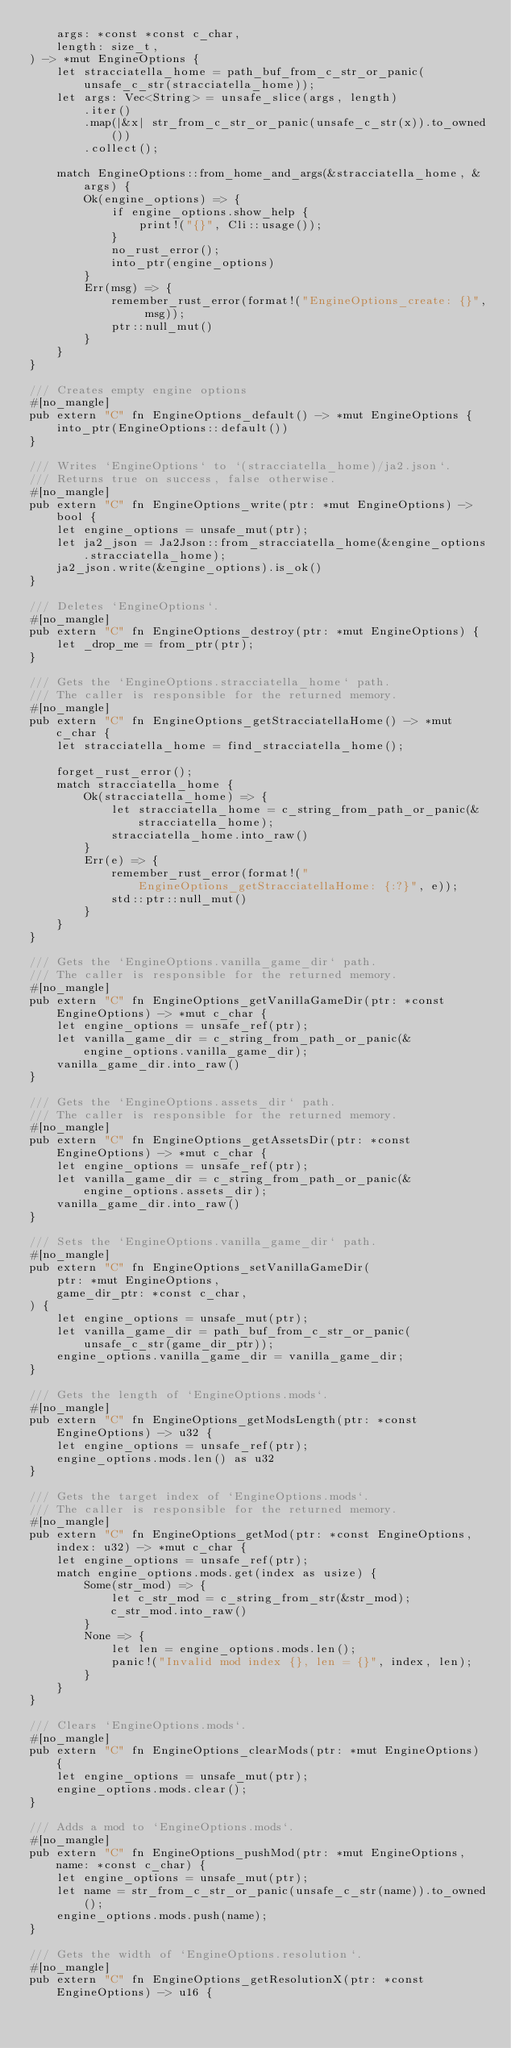Convert code to text. <code><loc_0><loc_0><loc_500><loc_500><_Rust_>    args: *const *const c_char,
    length: size_t,
) -> *mut EngineOptions {
    let stracciatella_home = path_buf_from_c_str_or_panic(unsafe_c_str(stracciatella_home));
    let args: Vec<String> = unsafe_slice(args, length)
        .iter()
        .map(|&x| str_from_c_str_or_panic(unsafe_c_str(x)).to_owned())
        .collect();

    match EngineOptions::from_home_and_args(&stracciatella_home, &args) {
        Ok(engine_options) => {
            if engine_options.show_help {
                print!("{}", Cli::usage());
            }
            no_rust_error();
            into_ptr(engine_options)
        }
        Err(msg) => {
            remember_rust_error(format!("EngineOptions_create: {}", msg));
            ptr::null_mut()
        }
    }
}

/// Creates empty engine options
#[no_mangle]
pub extern "C" fn EngineOptions_default() -> *mut EngineOptions {
    into_ptr(EngineOptions::default())
}

/// Writes `EngineOptions` to `(stracciatella_home)/ja2.json`.
/// Returns true on success, false otherwise.
#[no_mangle]
pub extern "C" fn EngineOptions_write(ptr: *mut EngineOptions) -> bool {
    let engine_options = unsafe_mut(ptr);
    let ja2_json = Ja2Json::from_stracciatella_home(&engine_options.stracciatella_home);
    ja2_json.write(&engine_options).is_ok()
}

/// Deletes `EngineOptions`.
#[no_mangle]
pub extern "C" fn EngineOptions_destroy(ptr: *mut EngineOptions) {
    let _drop_me = from_ptr(ptr);
}

/// Gets the `EngineOptions.stracciatella_home` path.
/// The caller is responsible for the returned memory.
#[no_mangle]
pub extern "C" fn EngineOptions_getStracciatellaHome() -> *mut c_char {
    let stracciatella_home = find_stracciatella_home();

    forget_rust_error();
    match stracciatella_home {
        Ok(stracciatella_home) => {
            let stracciatella_home = c_string_from_path_or_panic(&stracciatella_home);
            stracciatella_home.into_raw()
        }
        Err(e) => {
            remember_rust_error(format!("EngineOptions_getStracciatellaHome: {:?}", e));
            std::ptr::null_mut()
        }
    }
}

/// Gets the `EngineOptions.vanilla_game_dir` path.
/// The caller is responsible for the returned memory.
#[no_mangle]
pub extern "C" fn EngineOptions_getVanillaGameDir(ptr: *const EngineOptions) -> *mut c_char {
    let engine_options = unsafe_ref(ptr);
    let vanilla_game_dir = c_string_from_path_or_panic(&engine_options.vanilla_game_dir);
    vanilla_game_dir.into_raw()
}

/// Gets the `EngineOptions.assets_dir` path.
/// The caller is responsible for the returned memory.
#[no_mangle]
pub extern "C" fn EngineOptions_getAssetsDir(ptr: *const EngineOptions) -> *mut c_char {
    let engine_options = unsafe_ref(ptr);
    let vanilla_game_dir = c_string_from_path_or_panic(&engine_options.assets_dir);
    vanilla_game_dir.into_raw()
}

/// Sets the `EngineOptions.vanilla_game_dir` path.
#[no_mangle]
pub extern "C" fn EngineOptions_setVanillaGameDir(
    ptr: *mut EngineOptions,
    game_dir_ptr: *const c_char,
) {
    let engine_options = unsafe_mut(ptr);
    let vanilla_game_dir = path_buf_from_c_str_or_panic(unsafe_c_str(game_dir_ptr));
    engine_options.vanilla_game_dir = vanilla_game_dir;
}

/// Gets the length of `EngineOptions.mods`.
#[no_mangle]
pub extern "C" fn EngineOptions_getModsLength(ptr: *const EngineOptions) -> u32 {
    let engine_options = unsafe_ref(ptr);
    engine_options.mods.len() as u32
}

/// Gets the target index of `EngineOptions.mods`.
/// The caller is responsible for the returned memory.
#[no_mangle]
pub extern "C" fn EngineOptions_getMod(ptr: *const EngineOptions, index: u32) -> *mut c_char {
    let engine_options = unsafe_ref(ptr);
    match engine_options.mods.get(index as usize) {
        Some(str_mod) => {
            let c_str_mod = c_string_from_str(&str_mod);
            c_str_mod.into_raw()
        }
        None => {
            let len = engine_options.mods.len();
            panic!("Invalid mod index {}, len = {}", index, len);
        }
    }
}

/// Clears `EngineOptions.mods`.
#[no_mangle]
pub extern "C" fn EngineOptions_clearMods(ptr: *mut EngineOptions) {
    let engine_options = unsafe_mut(ptr);
    engine_options.mods.clear();
}

/// Adds a mod to `EngineOptions.mods`.
#[no_mangle]
pub extern "C" fn EngineOptions_pushMod(ptr: *mut EngineOptions, name: *const c_char) {
    let engine_options = unsafe_mut(ptr);
    let name = str_from_c_str_or_panic(unsafe_c_str(name)).to_owned();
    engine_options.mods.push(name);
}

/// Gets the width of `EngineOptions.resolution`.
#[no_mangle]
pub extern "C" fn EngineOptions_getResolutionX(ptr: *const EngineOptions) -> u16 {</code> 